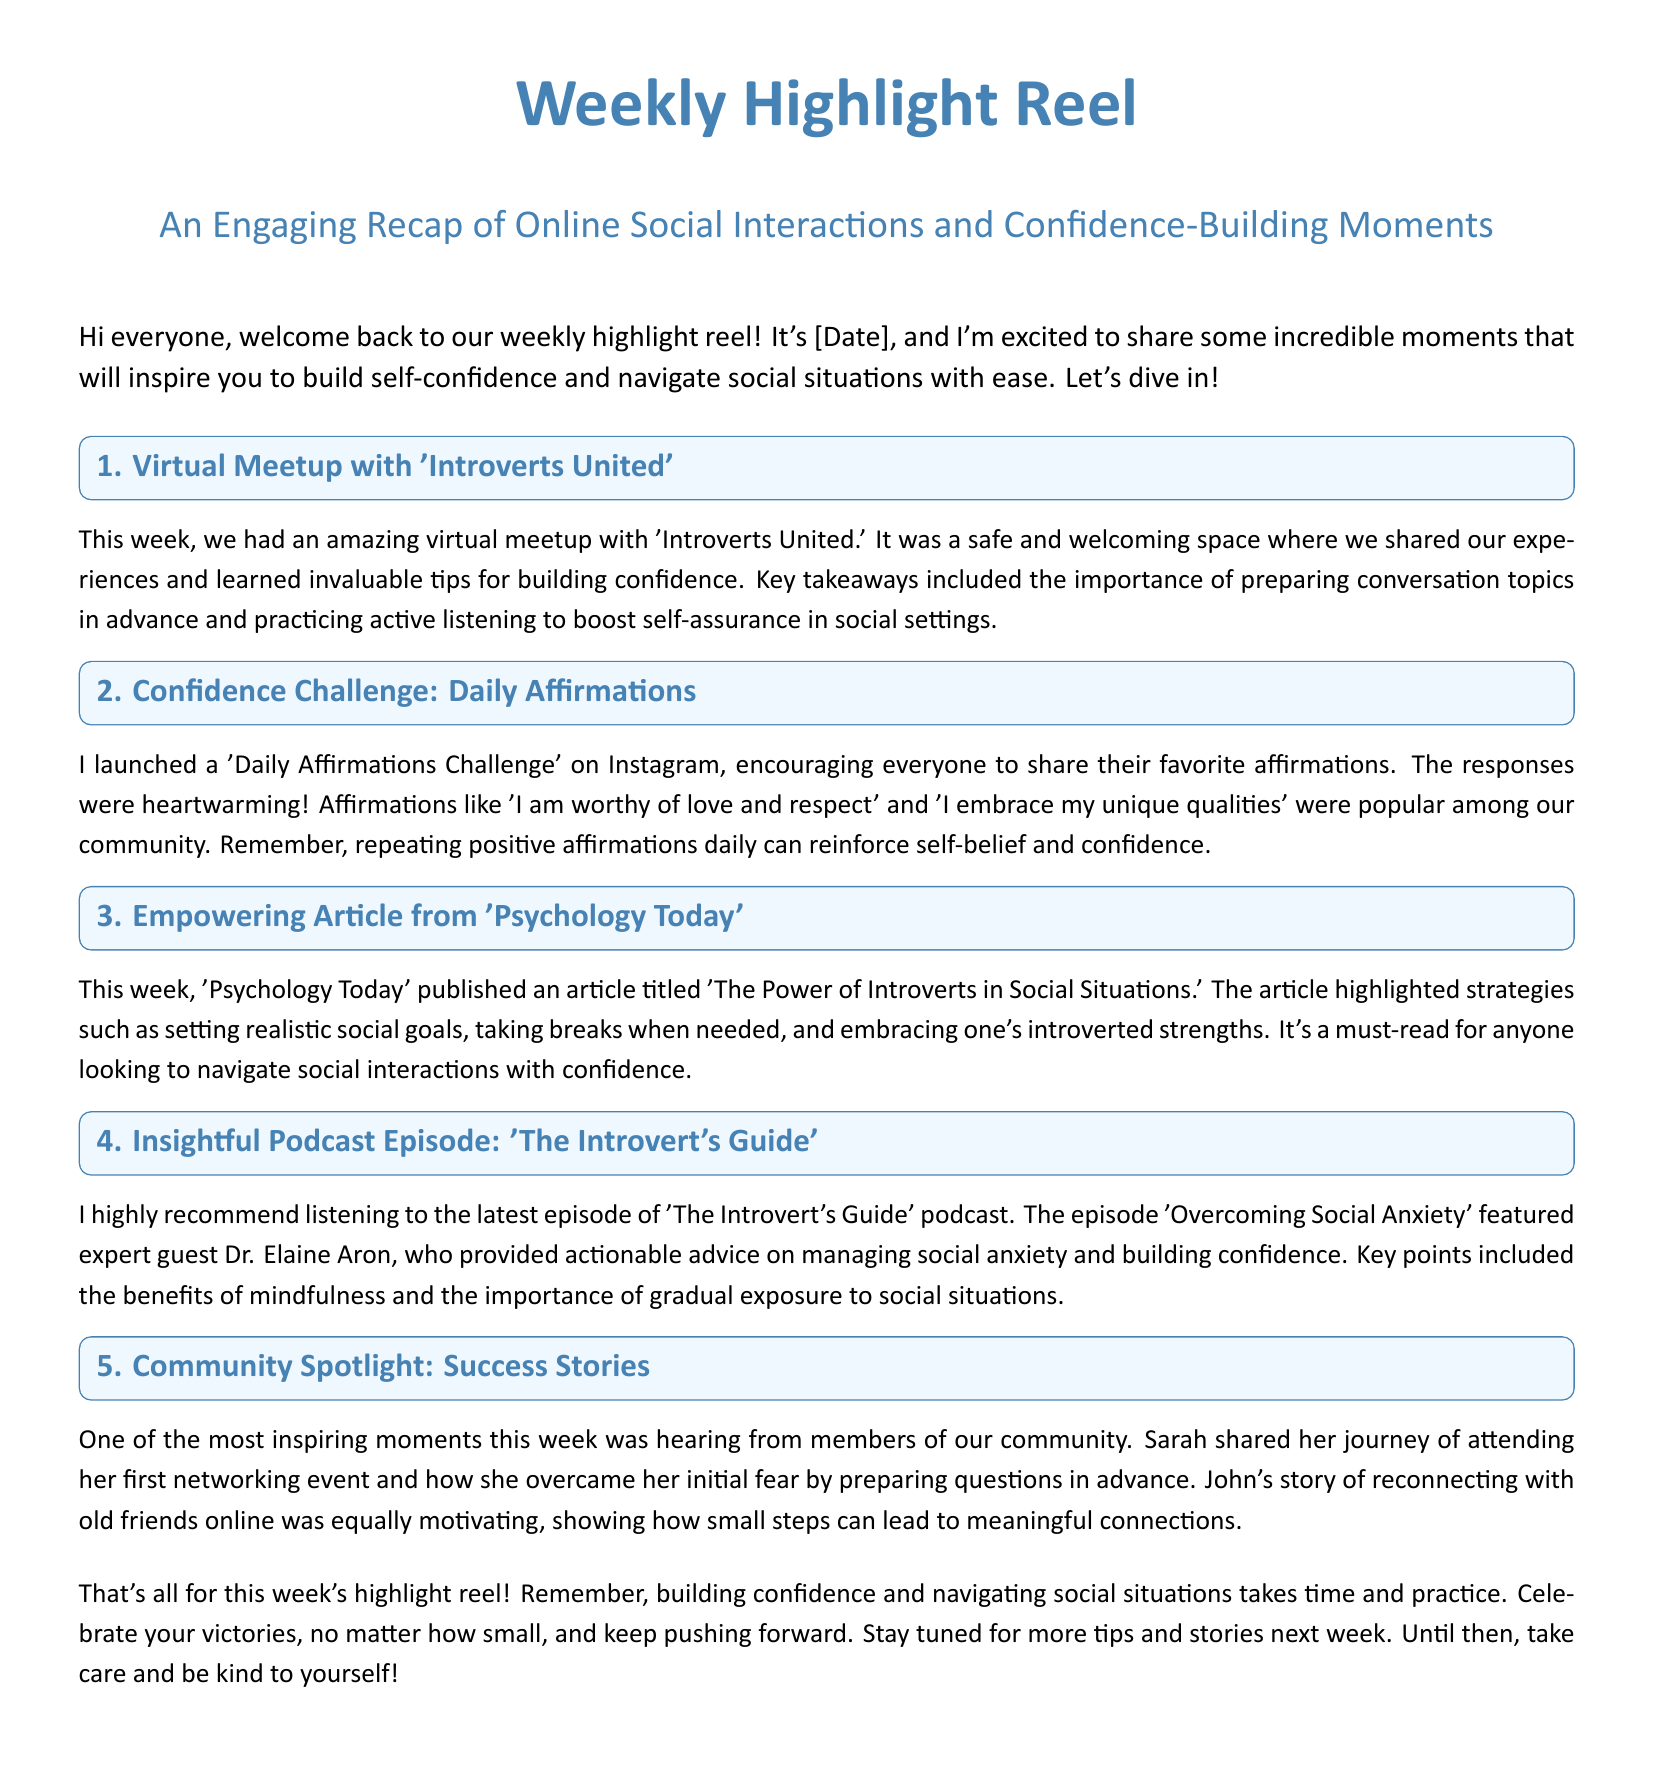What was the date of the weekly highlight reel? The document mentions it opens with "It's [Date]," indicating the specific date is part of the content.
Answer: [Date] What is the name of the community featured in the virtual meetup? The section discusses a meetup with 'Introverts United.'
Answer: 'Introverts United' What was one of the popular affirmations shared in the Daily Affirmations Challenge? The document lists affirmations like 'I am worthy of love and respect' that were popular among the community.
Answer: 'I am worthy of love and respect' Who was the guest featured in the podcast episode 'Overcoming Social Anxiety'? The podcast features expert guest Dr. Elaine Aron, as mentioned in the document.
Answer: Dr. Elaine Aron What is one of the strategies highlighted in the 'Psychology Today' article? The article mentions strategies such as setting realistic social goals as ways to gain confidence in social situations.
Answer: Setting realistic social goals What was a major theme in the community spotlight success stories? The success stories primarily revolved around members overcoming social fears and making connections, as indicated in the section.
Answer: Overcoming social fears How many key takeaways were listed from the virtual meetup? The document states there were several key takeaways but specifically mentions at least two.
Answer: Two What week was the highlight reel shared? The document states "This week," indicating it's referring to the current week of the highlight reel.
Answer: This week What is the tone of the weekly highlight reel? The overall message conveys encouragement and positivity regarding social interactions and confidence.
Answer: Encouragement and positivity 